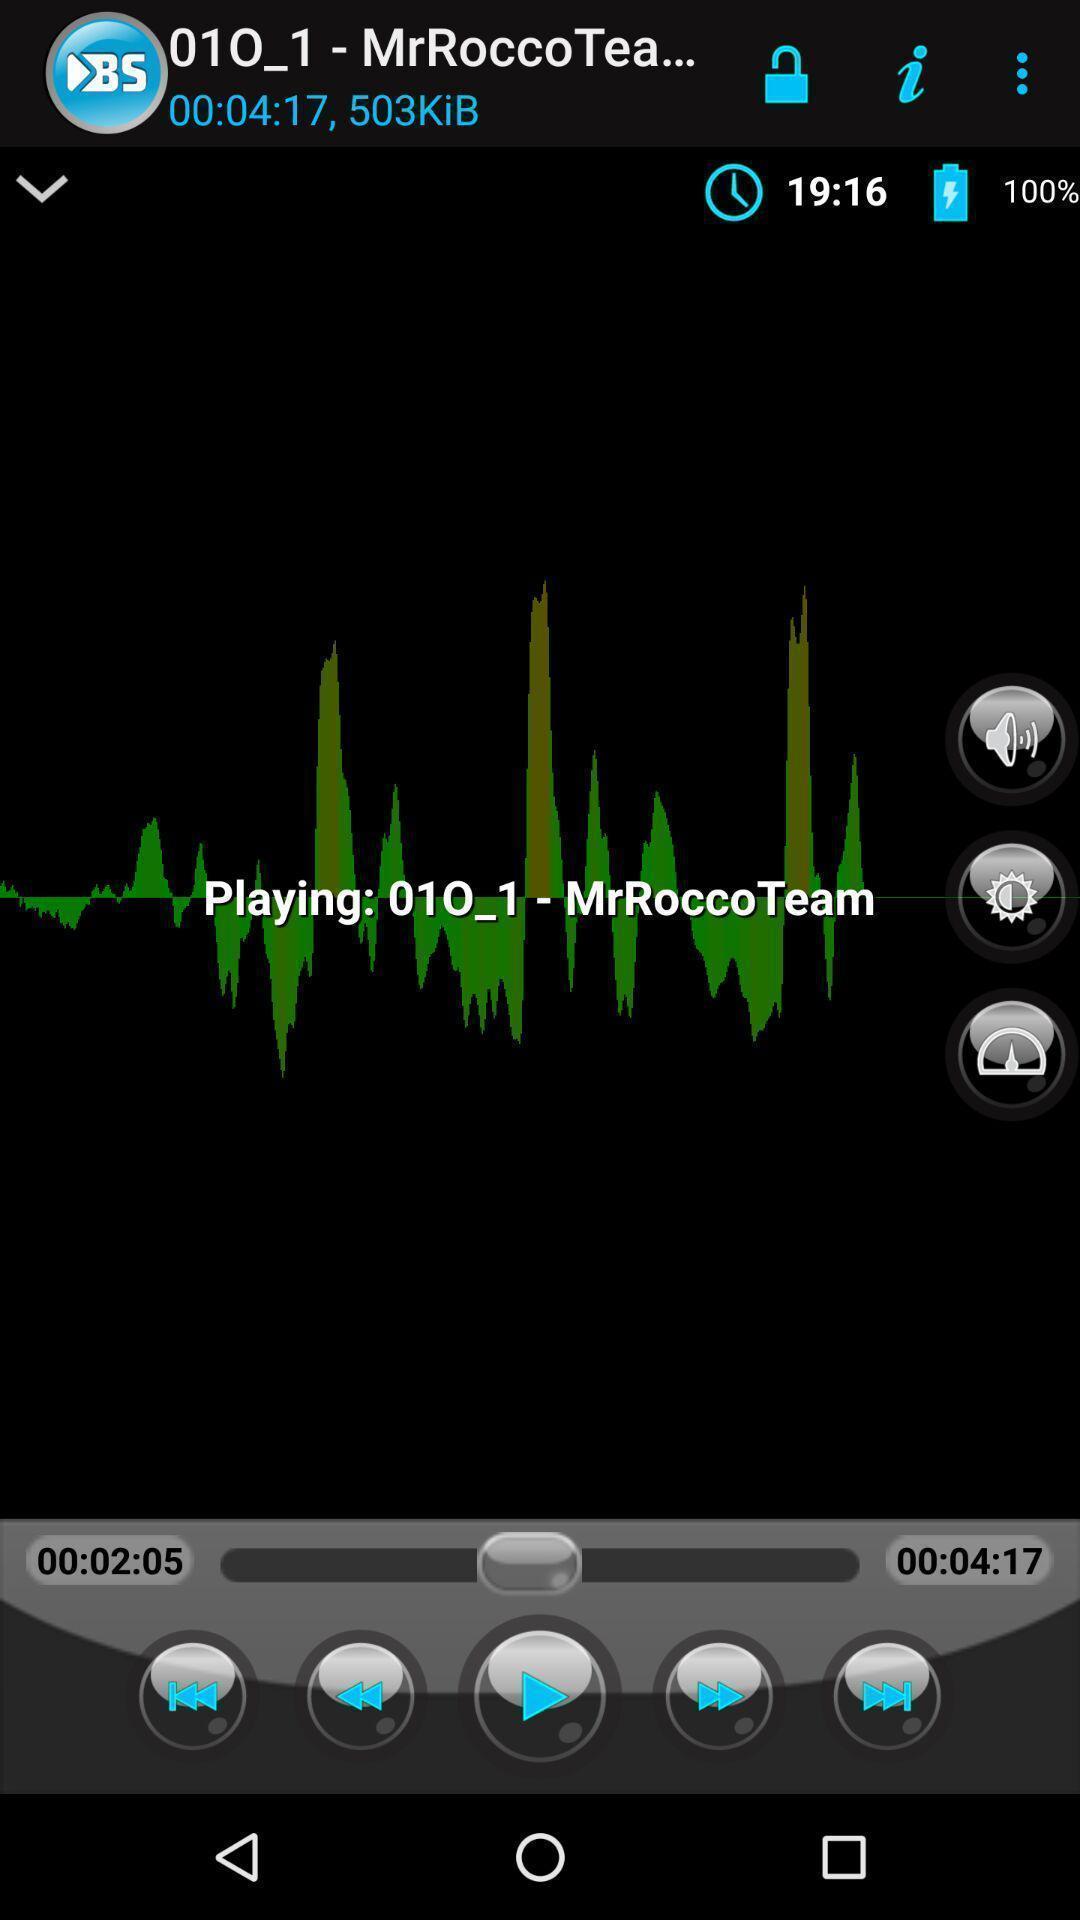Tell me about the visual elements in this screen capture. Screen displaying audio player in app. 